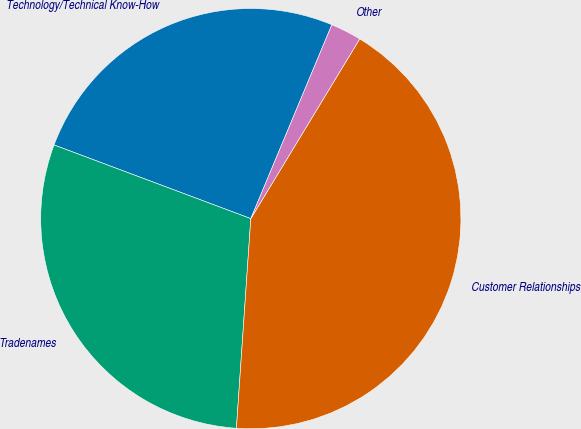Convert chart. <chart><loc_0><loc_0><loc_500><loc_500><pie_chart><fcel>Technology/Technical Know-How<fcel>Tradenames<fcel>Customer Relationships<fcel>Other<nl><fcel>25.6%<fcel>29.61%<fcel>42.42%<fcel>2.37%<nl></chart> 